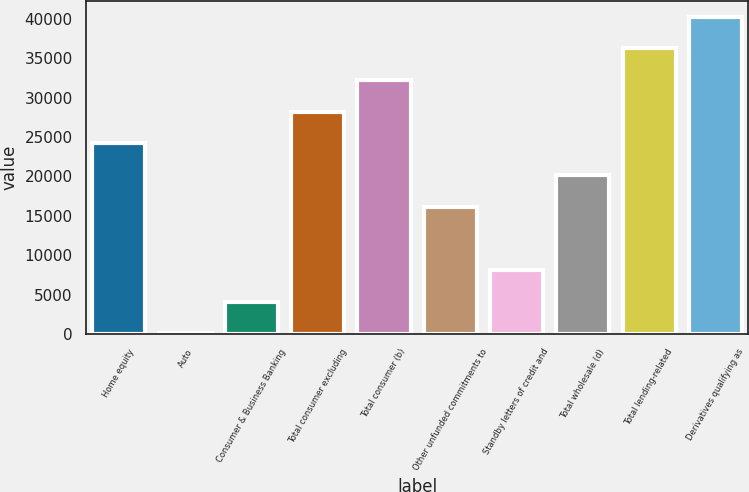Convert chart. <chart><loc_0><loc_0><loc_500><loc_500><bar_chart><fcel>Home equity<fcel>Auto<fcel>Consumer & Business Banking<fcel>Total consumer excluding<fcel>Total consumer (b)<fcel>Other unfunded commitments to<fcel>Standby letters of credit and<fcel>Total wholesale (d)<fcel>Total lending-related<fcel>Derivatives qualifying as<nl><fcel>24195.8<fcel>101<fcel>4116.8<fcel>28211.6<fcel>32227.4<fcel>16164.2<fcel>8132.6<fcel>20180<fcel>36243.2<fcel>40259<nl></chart> 